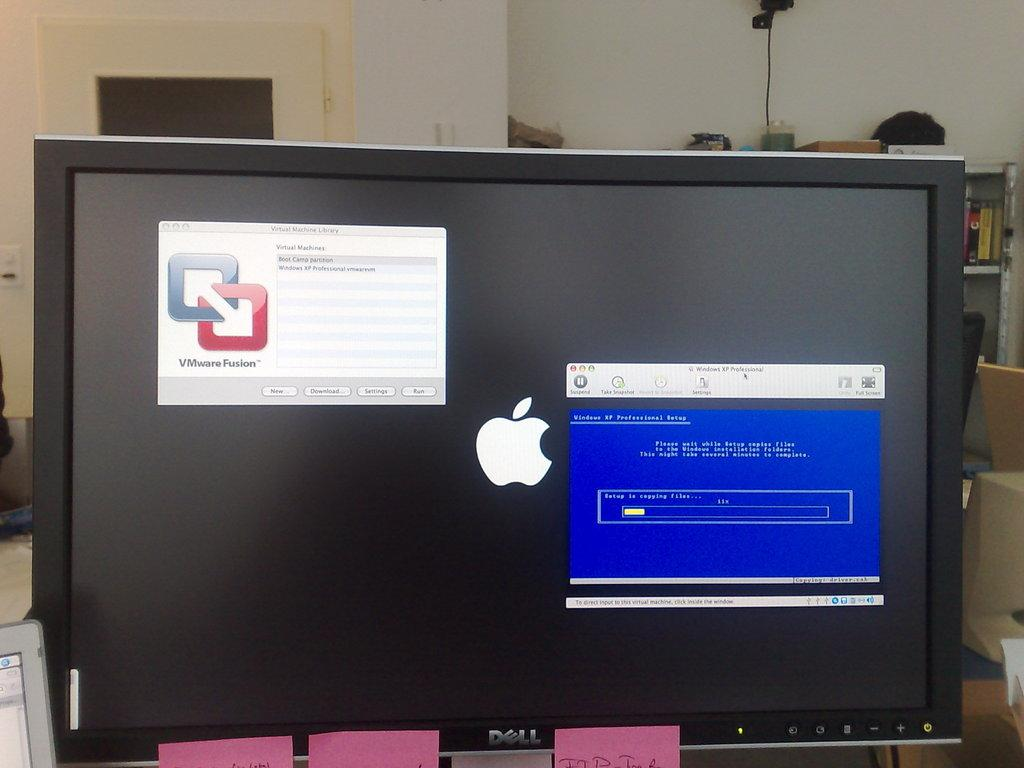<image>
Render a clear and concise summary of the photo. A Dell computer monitor is covered in sticky notes. 